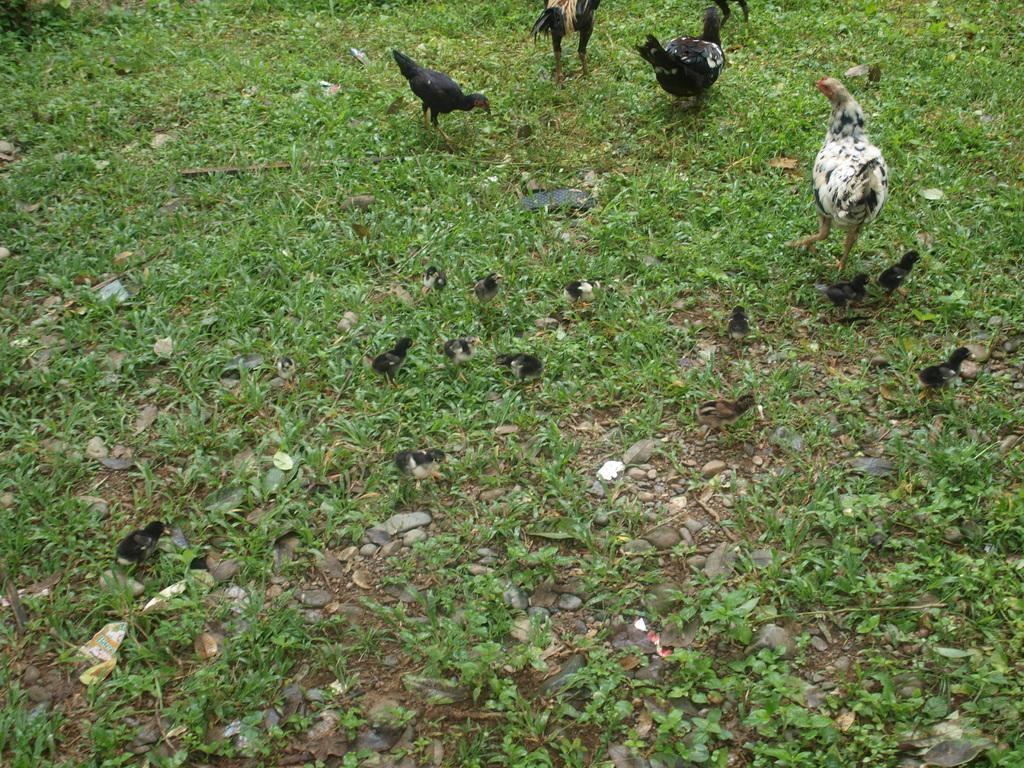Describe this image in one or two sentences. In this image we can see hens and chicks. At the bottom there is grass. 